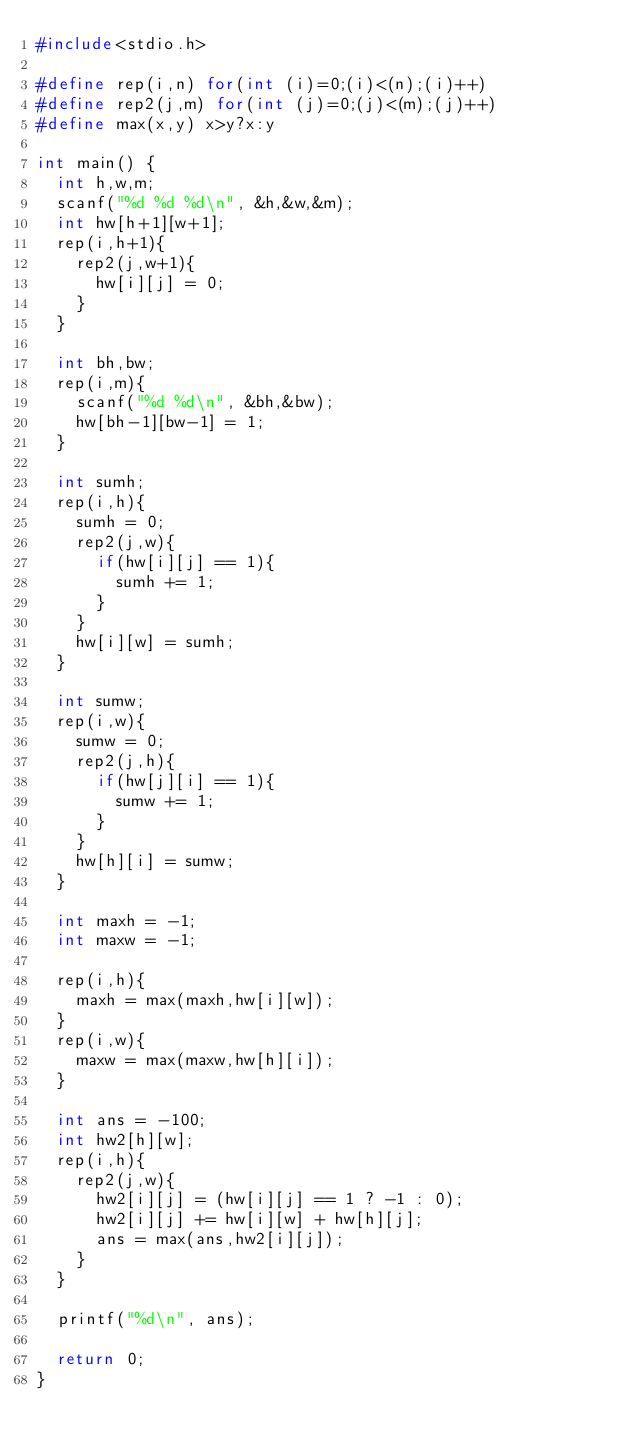<code> <loc_0><loc_0><loc_500><loc_500><_C_>#include<stdio.h>

#define rep(i,n) for(int (i)=0;(i)<(n);(i)++)
#define rep2(j,m) for(int (j)=0;(j)<(m);(j)++)
#define max(x,y) x>y?x:y

int main() {
  int h,w,m;
  scanf("%d %d %d\n", &h,&w,&m);
  int hw[h+1][w+1];
  rep(i,h+1){
    rep2(j,w+1){
      hw[i][j] = 0;
    }
  }

  int bh,bw;
  rep(i,m){
    scanf("%d %d\n", &bh,&bw);
    hw[bh-1][bw-1] = 1;
  }

  int sumh;
  rep(i,h){
    sumh = 0;
    rep2(j,w){
      if(hw[i][j] == 1){
        sumh += 1;
      }
    }
    hw[i][w] = sumh;
  }

  int sumw;
  rep(i,w){
    sumw = 0;
    rep2(j,h){
      if(hw[j][i] == 1){
        sumw += 1;
      }
    }
    hw[h][i] = sumw;
  }

  int maxh = -1;
  int maxw = -1;

  rep(i,h){
    maxh = max(maxh,hw[i][w]);
  }
  rep(i,w){
    maxw = max(maxw,hw[h][i]);
  }

  int ans = -100;
  int hw2[h][w];
  rep(i,h){
    rep2(j,w){
      hw2[i][j] = (hw[i][j] == 1 ? -1 : 0);
      hw2[i][j] += hw[i][w] + hw[h][j];
      ans = max(ans,hw2[i][j]);
    }
  }

  printf("%d\n", ans);

  return 0;
}
</code> 